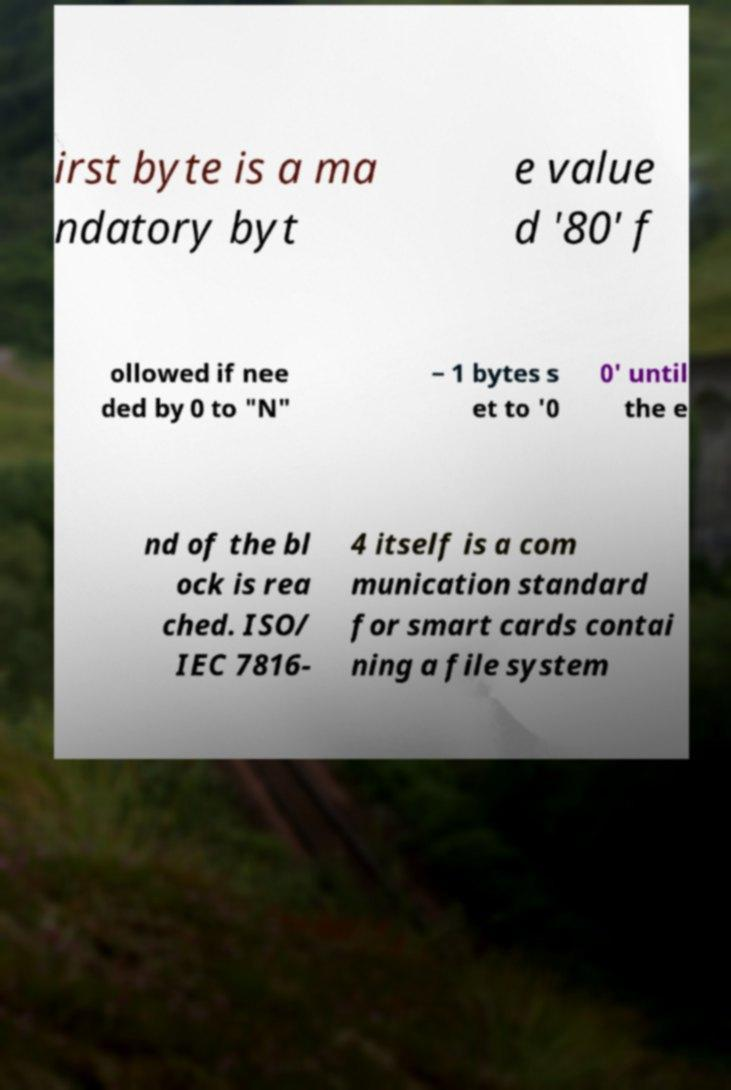Can you accurately transcribe the text from the provided image for me? irst byte is a ma ndatory byt e value d '80' f ollowed if nee ded by 0 to "N" − 1 bytes s et to '0 0' until the e nd of the bl ock is rea ched. ISO/ IEC 7816- 4 itself is a com munication standard for smart cards contai ning a file system 